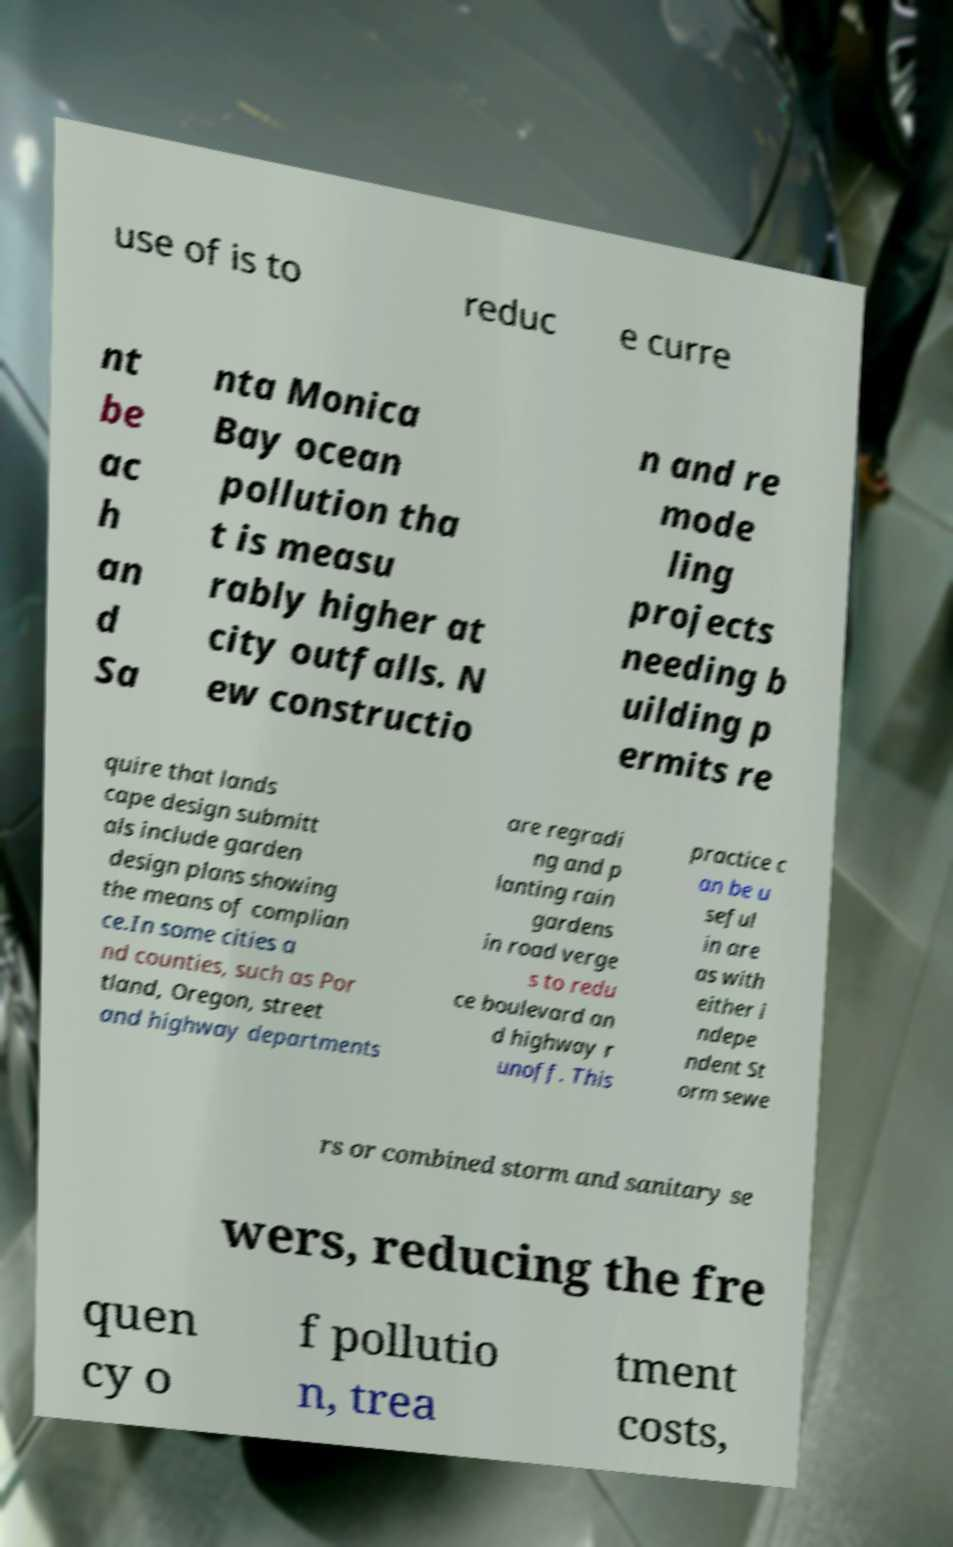Can you read and provide the text displayed in the image?This photo seems to have some interesting text. Can you extract and type it out for me? use of is to reduc e curre nt be ac h an d Sa nta Monica Bay ocean pollution tha t is measu rably higher at city outfalls. N ew constructio n and re mode ling projects needing b uilding p ermits re quire that lands cape design submitt als include garden design plans showing the means of complian ce.In some cities a nd counties, such as Por tland, Oregon, street and highway departments are regradi ng and p lanting rain gardens in road verge s to redu ce boulevard an d highway r unoff. This practice c an be u seful in are as with either i ndepe ndent St orm sewe rs or combined storm and sanitary se wers, reducing the fre quen cy o f pollutio n, trea tment costs, 